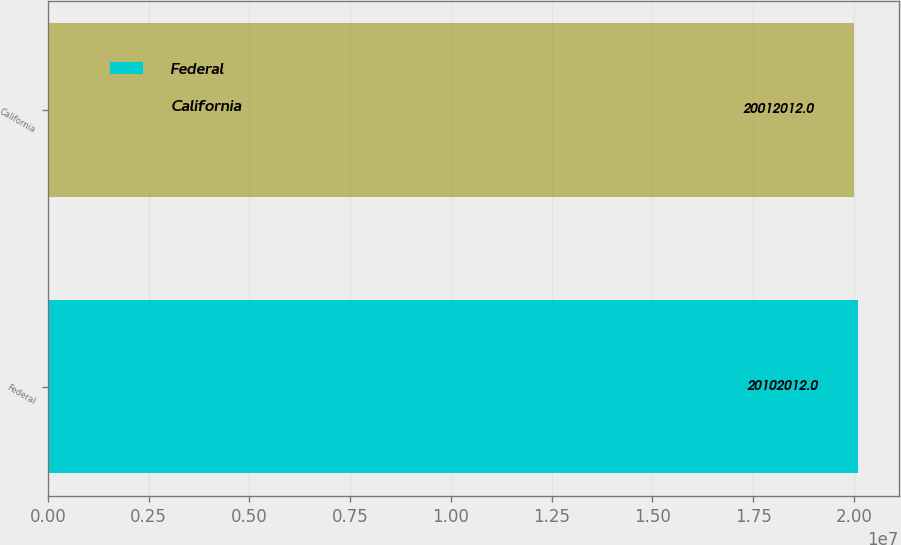Convert chart to OTSL. <chart><loc_0><loc_0><loc_500><loc_500><bar_chart><fcel>Federal<fcel>California<nl><fcel>2.0102e+07<fcel>2.0012e+07<nl></chart> 